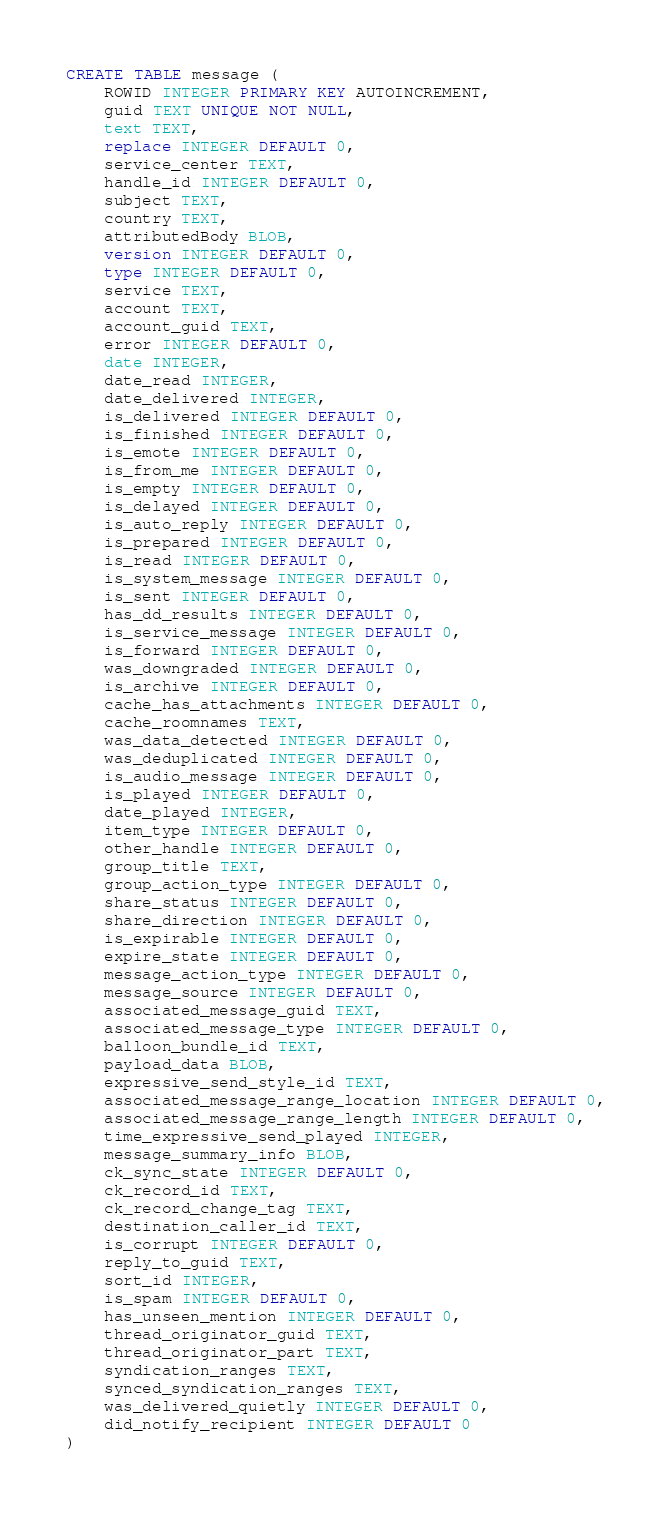<code> <loc_0><loc_0><loc_500><loc_500><_SQL_>CREATE TABLE message (
    ROWID INTEGER PRIMARY KEY AUTOINCREMENT,
    guid TEXT UNIQUE NOT NULL,
    text TEXT,
    replace INTEGER DEFAULT 0,
    service_center TEXT,
    handle_id INTEGER DEFAULT 0,
    subject TEXT,
    country TEXT,
    attributedBody BLOB,
    version INTEGER DEFAULT 0,
    type INTEGER DEFAULT 0,
    service TEXT,
    account TEXT,
    account_guid TEXT,
    error INTEGER DEFAULT 0,
    date INTEGER,
    date_read INTEGER,
    date_delivered INTEGER,
    is_delivered INTEGER DEFAULT 0,
    is_finished INTEGER DEFAULT 0,
    is_emote INTEGER DEFAULT 0,
    is_from_me INTEGER DEFAULT 0,
    is_empty INTEGER DEFAULT 0,
    is_delayed INTEGER DEFAULT 0,
    is_auto_reply INTEGER DEFAULT 0,
    is_prepared INTEGER DEFAULT 0,
    is_read INTEGER DEFAULT 0,
    is_system_message INTEGER DEFAULT 0,
    is_sent INTEGER DEFAULT 0,
    has_dd_results INTEGER DEFAULT 0,
    is_service_message INTEGER DEFAULT 0,
    is_forward INTEGER DEFAULT 0,
    was_downgraded INTEGER DEFAULT 0,
    is_archive INTEGER DEFAULT 0,
    cache_has_attachments INTEGER DEFAULT 0,
    cache_roomnames TEXT,
    was_data_detected INTEGER DEFAULT 0,
    was_deduplicated INTEGER DEFAULT 0,
    is_audio_message INTEGER DEFAULT 0,
    is_played INTEGER DEFAULT 0,
    date_played INTEGER,
    item_type INTEGER DEFAULT 0,
    other_handle INTEGER DEFAULT 0,
    group_title TEXT,
    group_action_type INTEGER DEFAULT 0,
    share_status INTEGER DEFAULT 0,
    share_direction INTEGER DEFAULT 0,
    is_expirable INTEGER DEFAULT 0,
    expire_state INTEGER DEFAULT 0,
    message_action_type INTEGER DEFAULT 0,
    message_source INTEGER DEFAULT 0,
    associated_message_guid TEXT,
    associated_message_type INTEGER DEFAULT 0,
    balloon_bundle_id TEXT,
    payload_data BLOB,
    expressive_send_style_id TEXT,
    associated_message_range_location INTEGER DEFAULT 0,
    associated_message_range_length INTEGER DEFAULT 0,
    time_expressive_send_played INTEGER,
    message_summary_info BLOB,
    ck_sync_state INTEGER DEFAULT 0,
    ck_record_id TEXT,
    ck_record_change_tag TEXT,
    destination_caller_id TEXT,
    is_corrupt INTEGER DEFAULT 0,
    reply_to_guid TEXT,
    sort_id INTEGER,
    is_spam INTEGER DEFAULT 0,
    has_unseen_mention INTEGER DEFAULT 0,
    thread_originator_guid TEXT,
    thread_originator_part TEXT,
    syndication_ranges TEXT,
    synced_syndication_ranges TEXT,
    was_delivered_quietly INTEGER DEFAULT 0,
    did_notify_recipient INTEGER DEFAULT 0
)</code> 